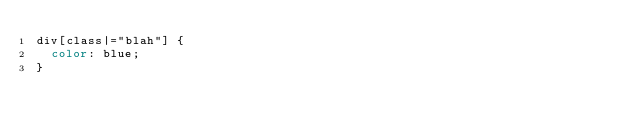<code> <loc_0><loc_0><loc_500><loc_500><_CSS_>div[class|="blah"] {
  color: blue;
}
</code> 